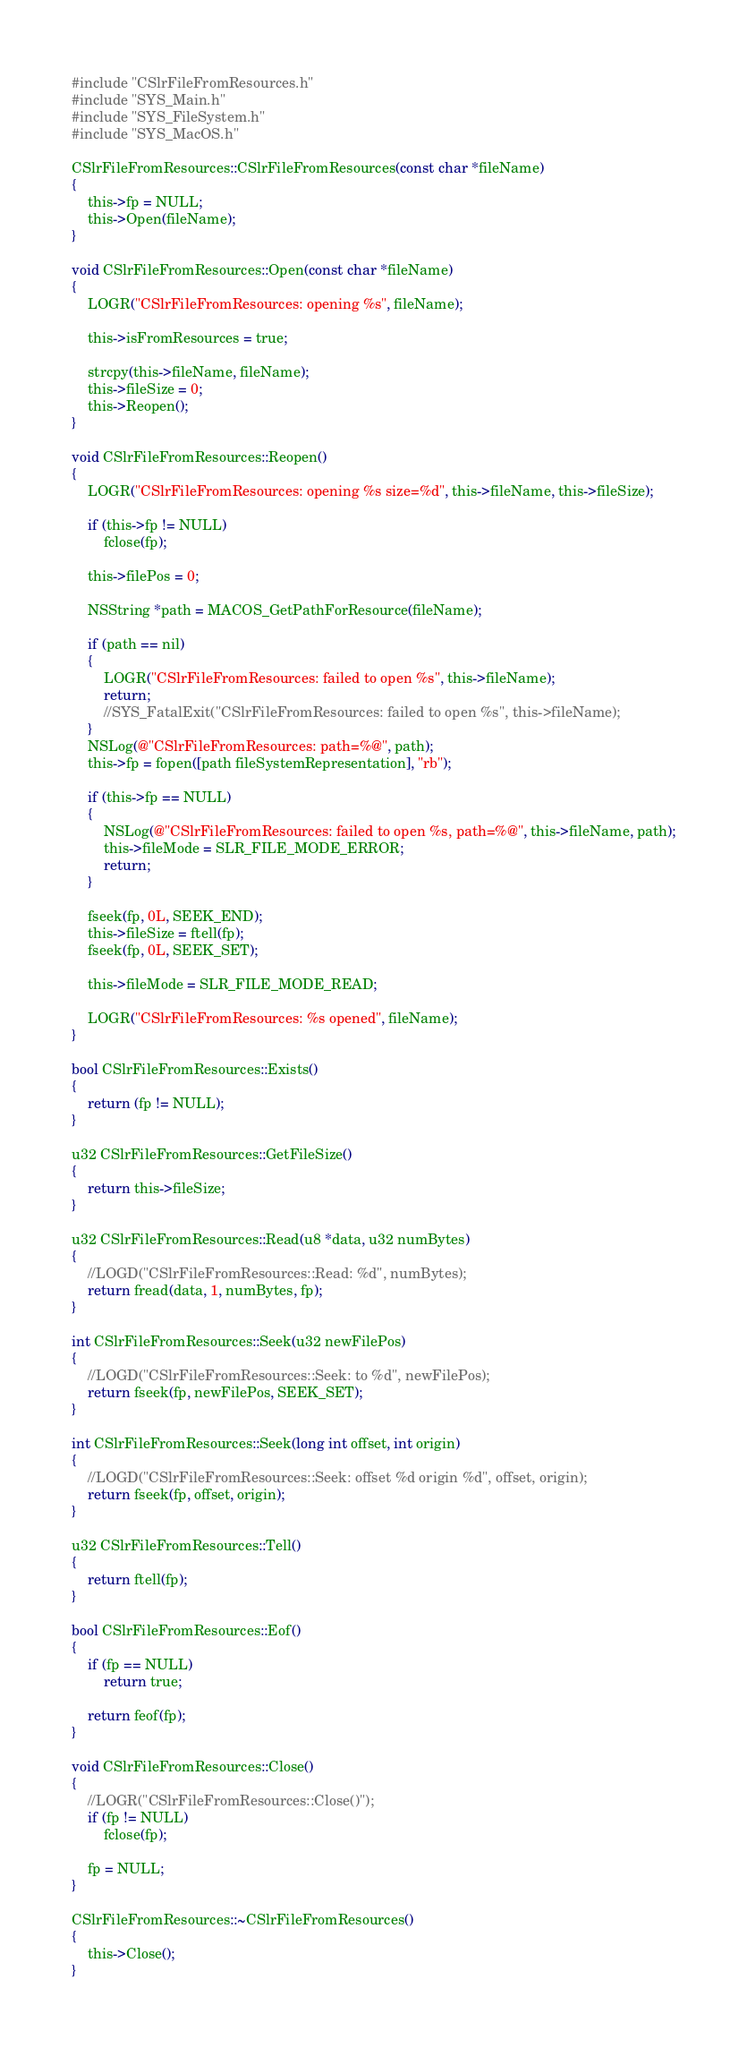Convert code to text. <code><loc_0><loc_0><loc_500><loc_500><_ObjectiveC_>#include "CSlrFileFromResources.h"
#include "SYS_Main.h"
#include "SYS_FileSystem.h"
#include "SYS_MacOS.h"

CSlrFileFromResources::CSlrFileFromResources(const char *fileName)
{
	this->fp = NULL;
	this->Open(fileName);
}

void CSlrFileFromResources::Open(const char *fileName)
{
	LOGR("CSlrFileFromResources: opening %s", fileName);

	this->isFromResources = true;
	
	strcpy(this->fileName, fileName);
	this->fileSize = 0;
	this->Reopen();
}

void CSlrFileFromResources::Reopen()
{
	LOGR("CSlrFileFromResources: opening %s size=%d", this->fileName, this->fileSize);

	if (this->fp != NULL)
		fclose(fp);

	this->filePos = 0;

	NSString *path = MACOS_GetPathForResource(fileName);
	
	if (path == nil)
	{
		LOGR("CSlrFileFromResources: failed to open %s", this->fileName);
		return; 
		//SYS_FatalExit("CSlrFileFromResources: failed to open %s", this->fileName);
	}
	NSLog(@"CSlrFileFromResources: path=%@", path);
	this->fp = fopen([path fileSystemRepresentation], "rb");

	if (this->fp == NULL)
	{
		NSLog(@"CSlrFileFromResources: failed to open %s, path=%@", this->fileName, path);
		this->fileMode = SLR_FILE_MODE_ERROR;
		return;
	}

	fseek(fp, 0L, SEEK_END);
	this->fileSize = ftell(fp);
	fseek(fp, 0L, SEEK_SET);

	this->fileMode = SLR_FILE_MODE_READ;

	LOGR("CSlrFileFromResources: %s opened", fileName);
}

bool CSlrFileFromResources::Exists()
{
	return (fp != NULL);
}

u32 CSlrFileFromResources::GetFileSize()
{
	return this->fileSize;
}

u32 CSlrFileFromResources::Read(u8 *data, u32 numBytes)
{
	//LOGD("CSlrFileFromResources::Read: %d", numBytes);
	return fread(data, 1, numBytes, fp);
}

int CSlrFileFromResources::Seek(u32 newFilePos)
{
	//LOGD("CSlrFileFromResources::Seek: to %d", newFilePos);
	return fseek(fp, newFilePos, SEEK_SET);
}

int CSlrFileFromResources::Seek(long int offset, int origin)
{
	//LOGD("CSlrFileFromResources::Seek: offset %d origin %d", offset, origin);
	return fseek(fp, offset, origin);
}

u32 CSlrFileFromResources::Tell()
{
	return ftell(fp);
}

bool CSlrFileFromResources::Eof()
{
	if (fp == NULL)
		return true;
	
	return feof(fp);
}

void CSlrFileFromResources::Close()
{
	//LOGR("CSlrFileFromResources::Close()");
	if (fp != NULL)
		fclose(fp);

	fp = NULL;
}

CSlrFileFromResources::~CSlrFileFromResources()
{
	this->Close();
}

</code> 